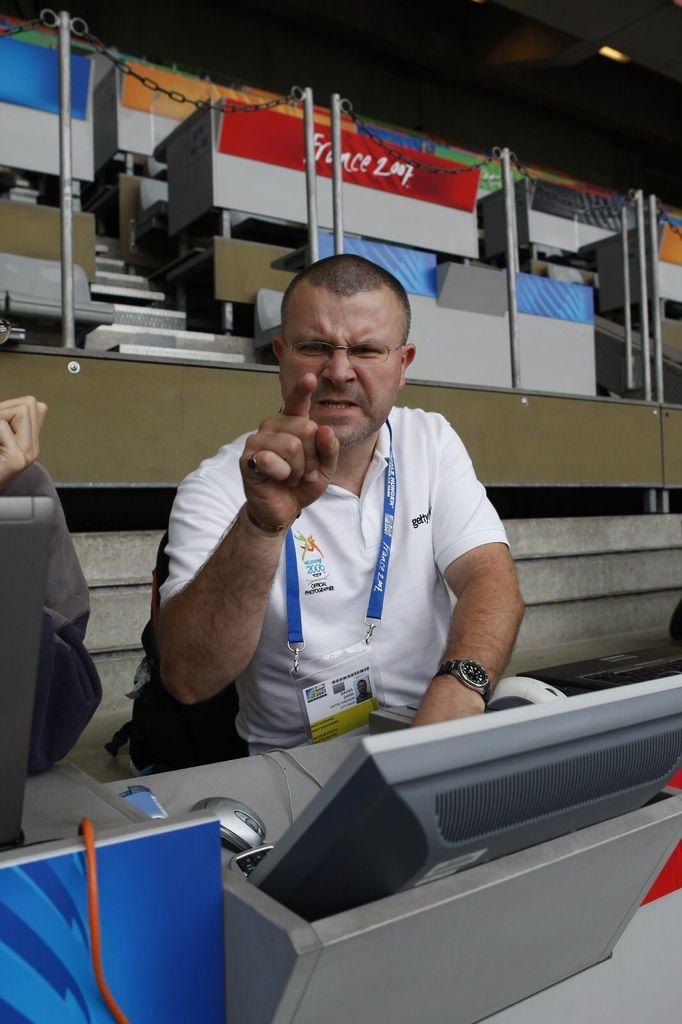What is the main object in the image? There is a computer in the image. Who or what is present with the computer? There is a person in the image. What architectural feature can be seen in the background? There are stairs in the background of the image. What is the source of light in the image? There is a light visible at the top of the image. What type of arithmetic problem is the person solving in the image? There is no indication in the image that the person is solving an arithmetic problem, so it cannot be determined from the picture. 